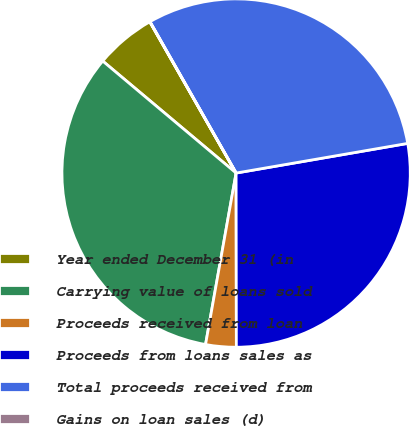Convert chart. <chart><loc_0><loc_0><loc_500><loc_500><pie_chart><fcel>Year ended December 31 (in<fcel>Carrying value of loans sold<fcel>Proceeds received from loan<fcel>Proceeds from loans sales as<fcel>Total proceeds received from<fcel>Gains on loan sales (d)<nl><fcel>5.63%<fcel>33.31%<fcel>2.83%<fcel>27.7%<fcel>30.51%<fcel>0.02%<nl></chart> 